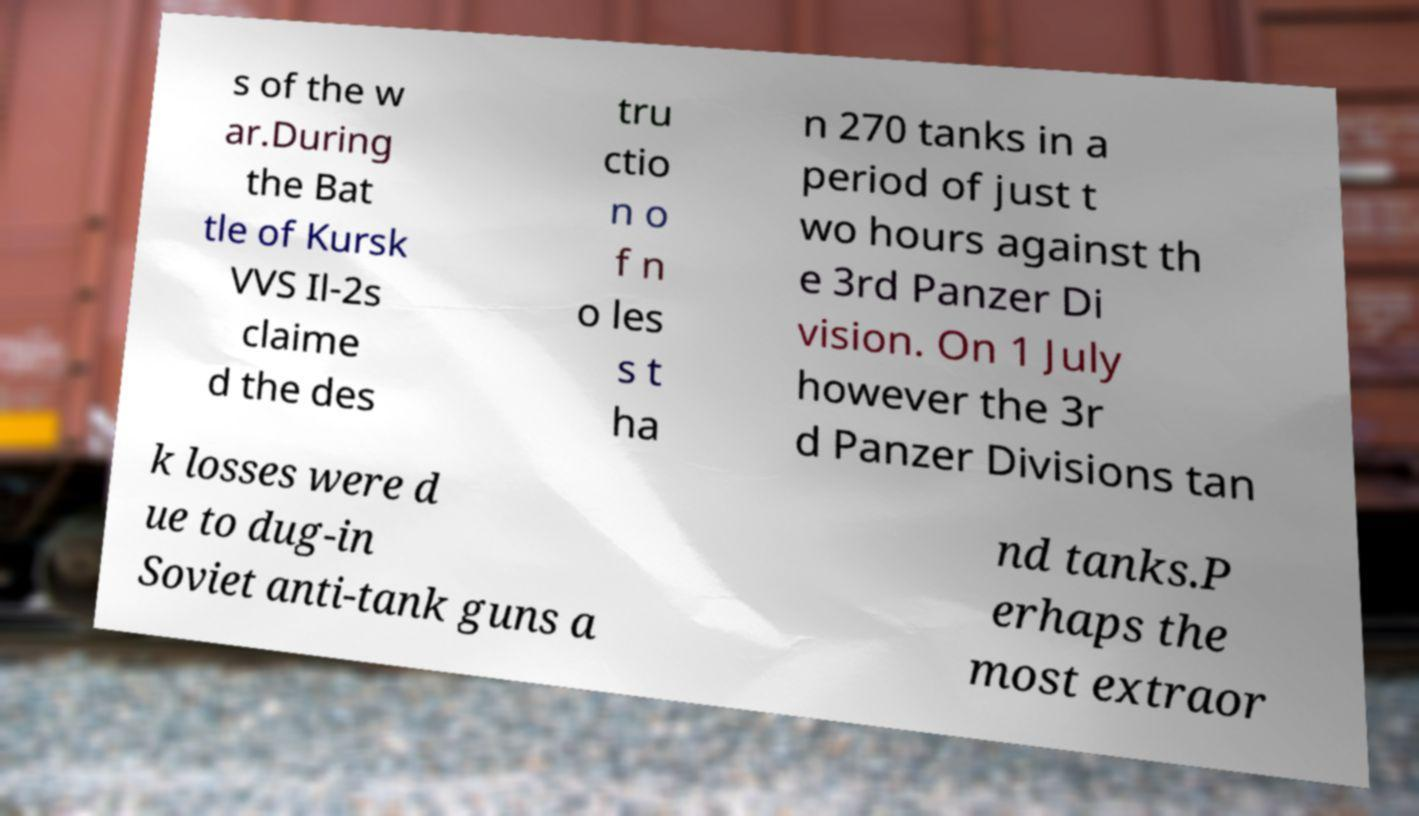Could you assist in decoding the text presented in this image and type it out clearly? s of the w ar.During the Bat tle of Kursk VVS Il-2s claime d the des tru ctio n o f n o les s t ha n 270 tanks in a period of just t wo hours against th e 3rd Panzer Di vision. On 1 July however the 3r d Panzer Divisions tan k losses were d ue to dug-in Soviet anti-tank guns a nd tanks.P erhaps the most extraor 